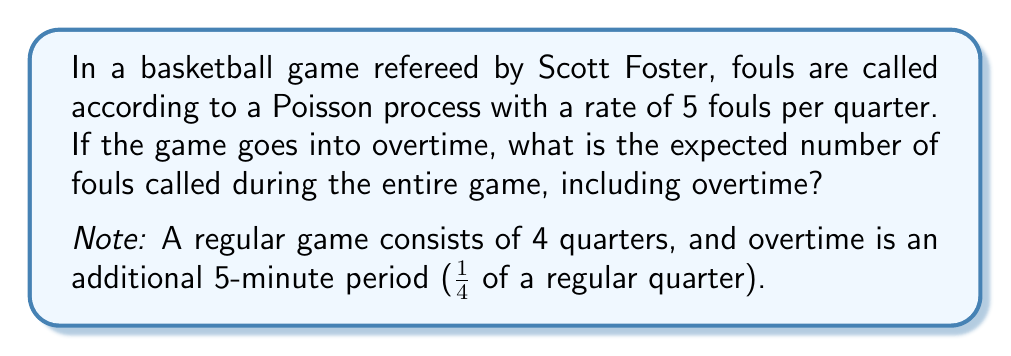Provide a solution to this math problem. Let's approach this step-by-step:

1) First, we need to calculate the rate for the entire game, including overtime:
   - Regular game: 4 quarters
   - Overtime: 1/4 of a quarter
   - Total: 4 + 1/4 = 4.25 quarters

2) The rate of the Poisson process is given as 5 fouls per quarter.

3) For a Poisson process, the expected number of events (in this case, fouls) in a given time interval is equal to the rate multiplied by the length of the interval.

4) Let $\lambda$ be the rate per quarter and $t$ be the number of quarters. Then the expected number of fouls $E[X]$ is:

   $$E[X] = \lambda t$$

5) Substituting our values:
   $$E[X] = 5 \cdot 4.25 = 21.25$$

Therefore, the expected number of fouls called during the entire game, including overtime, is 21.25.
Answer: 21.25 fouls 